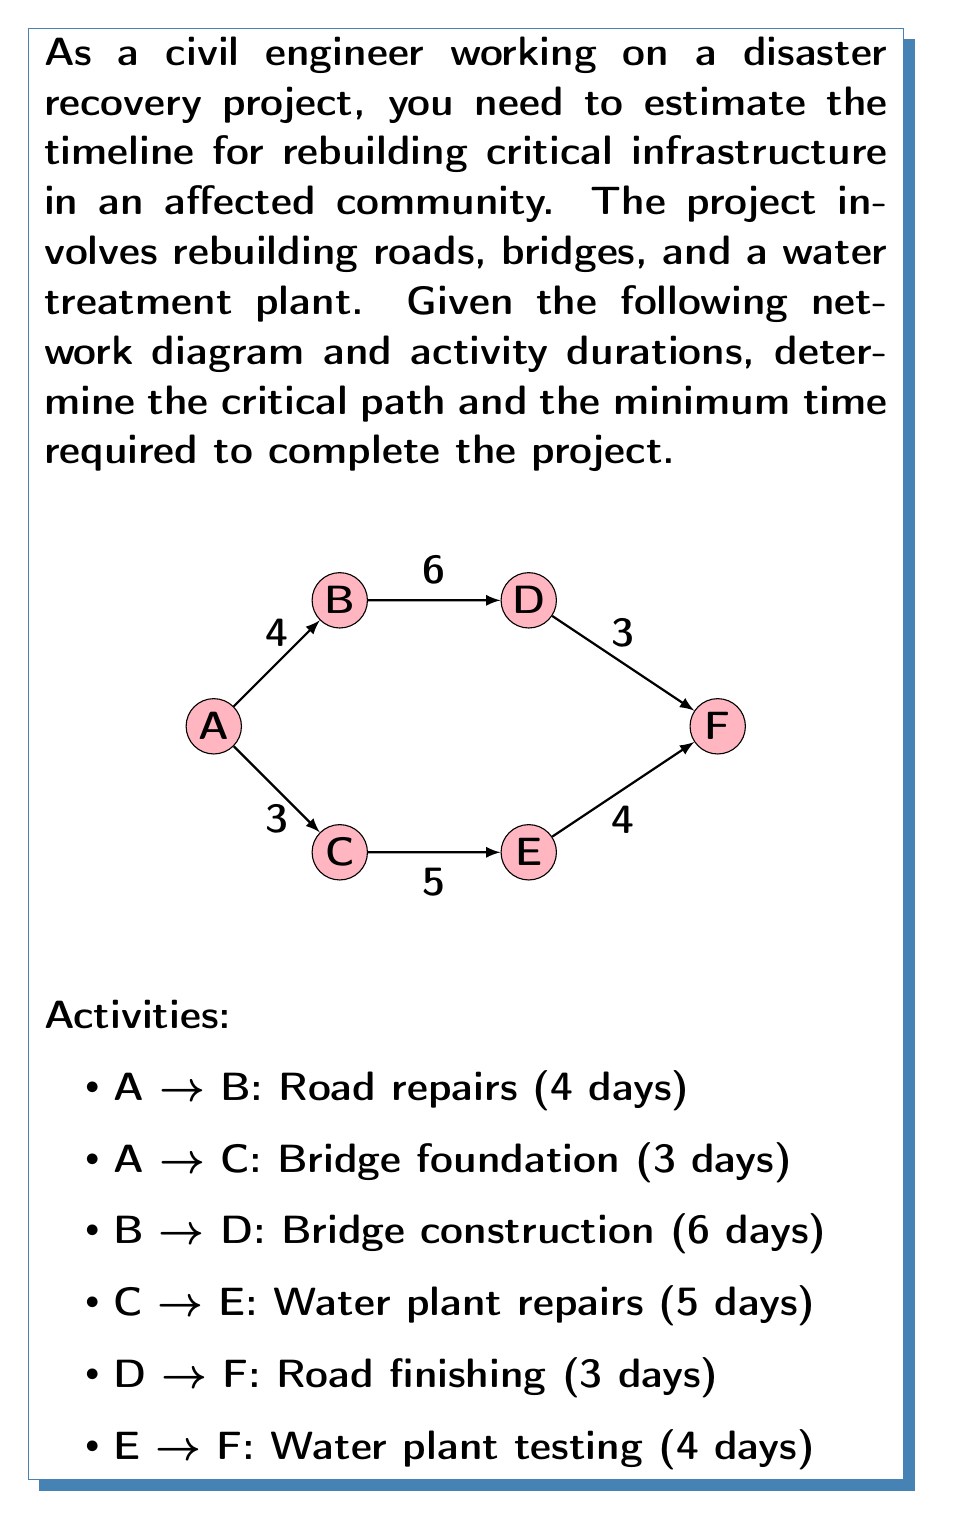Provide a solution to this math problem. To determine the critical path and minimum project duration, we'll use the forward pass and backward pass methods of critical path analysis.

Step 1: Forward Pass
Start with node A at time 0.

1. A → B: 0 + 4 = 4
2. A → C: 0 + 3 = 3
3. B → D: 4 + 6 = 10
4. C → E: 3 + 5 = 8
5. D → F: 10 + 3 = 13
6. E → F: 8 + 4 = 12

The project end time is the maximum of all paths to F, which is 13 days.

Step 2: Backward Pass
Start with node F at time 13.

1. F → D: 13 - 3 = 10
2. F → E: 13 - 4 = 9
3. D → B: 10 - 6 = 4
4. E → C: 9 - 5 = 4
5. B → A: 4 - 4 = 0
6. C → A: 4 - 3 = 1

Step 3: Calculate Float
Float = Late Start - Early Start
1. A → B: 4 - 0 = 0
2. A → C: 4 - 0 = 4
3. B → D: 4 - 4 = 0
4. C → E: 4 - 3 = 1
5. D → F: 10 - 10 = 0
6. E → F: 9 - 8 = 1

Step 4: Identify Critical Path
The critical path consists of activities with zero float:
A → B → D → F

Therefore, the critical path is: Road repairs → Bridge construction → Road finishing
Answer: 13 days; Critical path: A → B → D → F 